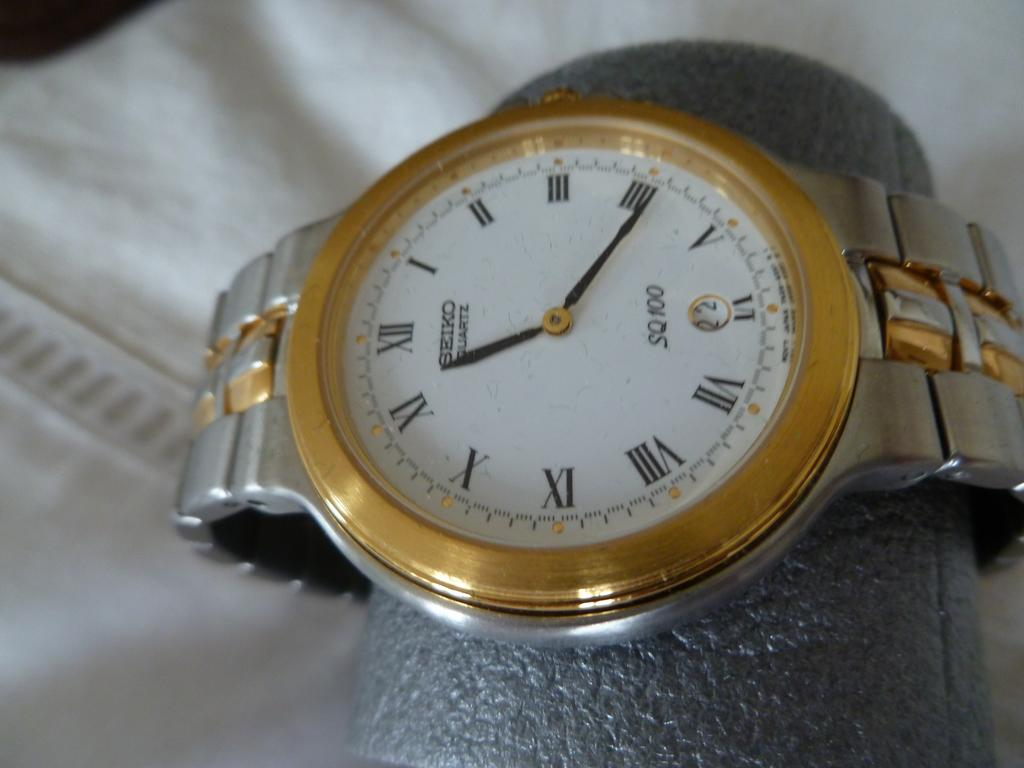<image>
Provide a brief description of the given image. A silver and gold Seiko Quartz SQ 100 watch is being displayed. 